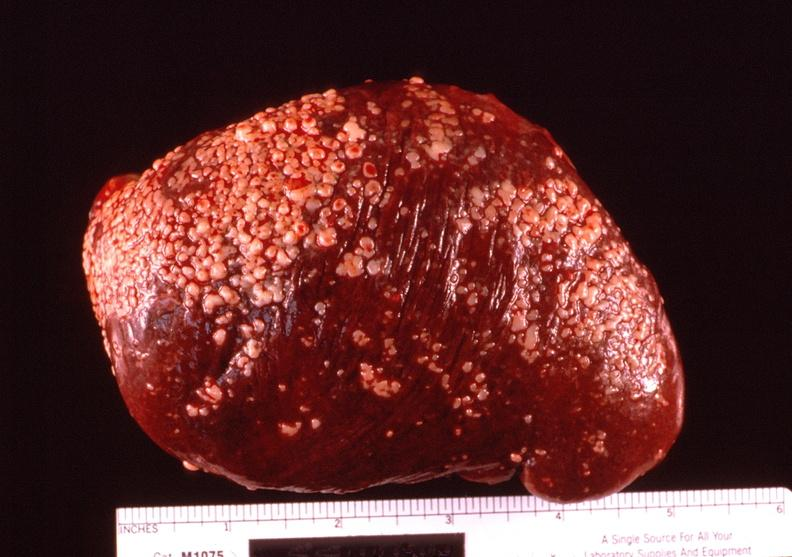s normal ovary present?
Answer the question using a single word or phrase. No 